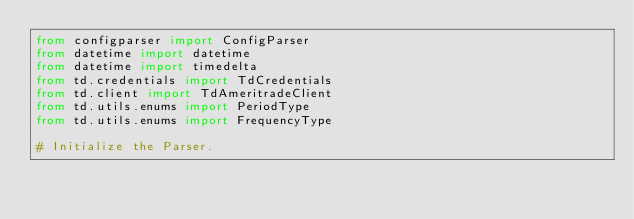<code> <loc_0><loc_0><loc_500><loc_500><_Python_>from configparser import ConfigParser
from datetime import datetime
from datetime import timedelta
from td.credentials import TdCredentials
from td.client import TdAmeritradeClient
from td.utils.enums import PeriodType
from td.utils.enums import FrequencyType

# Initialize the Parser.</code> 